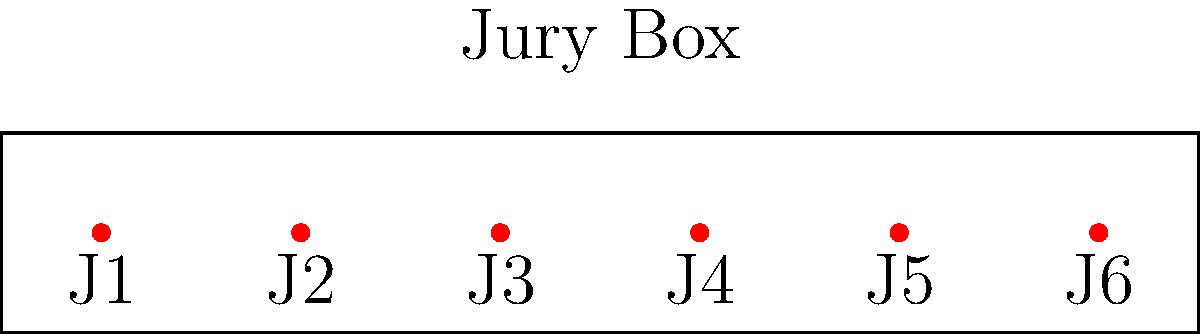In a courtroom, 6 jury members (J1, J2, J3, J4, J5, J6) are to be seated in a single row as shown in the diagram. If the judge decides that J1 and J6 must be seated at the ends (either end), how many different seating arrangements are possible? Let's approach this step-by-step:

1) We know that J1 and J6 must be at the ends, but they can switch places. This gives us 2 possibilities for their arrangement.

2) After placing J1 and J6, we have 4 seats left in the middle for the remaining 4 jurors (J2, J3, J4, J5).

3) The number of ways to arrange 4 people in 4 seats is a permutation, calculated as:

   $P(4,4) = 4! = 4 \times 3 \times 2 \times 1 = 24$

4) For each of the 2 possibilities of arranging J1 and J6, we have 24 ways to arrange the other 4 jurors.

5) By the multiplication principle, the total number of possible arrangements is:

   $2 \times 24 = 48$

Therefore, there are 48 different seating arrangements possible under these conditions.
Answer: 48 